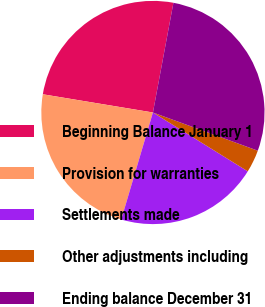Convert chart. <chart><loc_0><loc_0><loc_500><loc_500><pie_chart><fcel>Beginning Balance January 1<fcel>Provision for warranties<fcel>Settlements made<fcel>Other adjustments including<fcel>Ending balance December 31<nl><fcel>25.33%<fcel>23.03%<fcel>20.74%<fcel>3.28%<fcel>27.62%<nl></chart> 